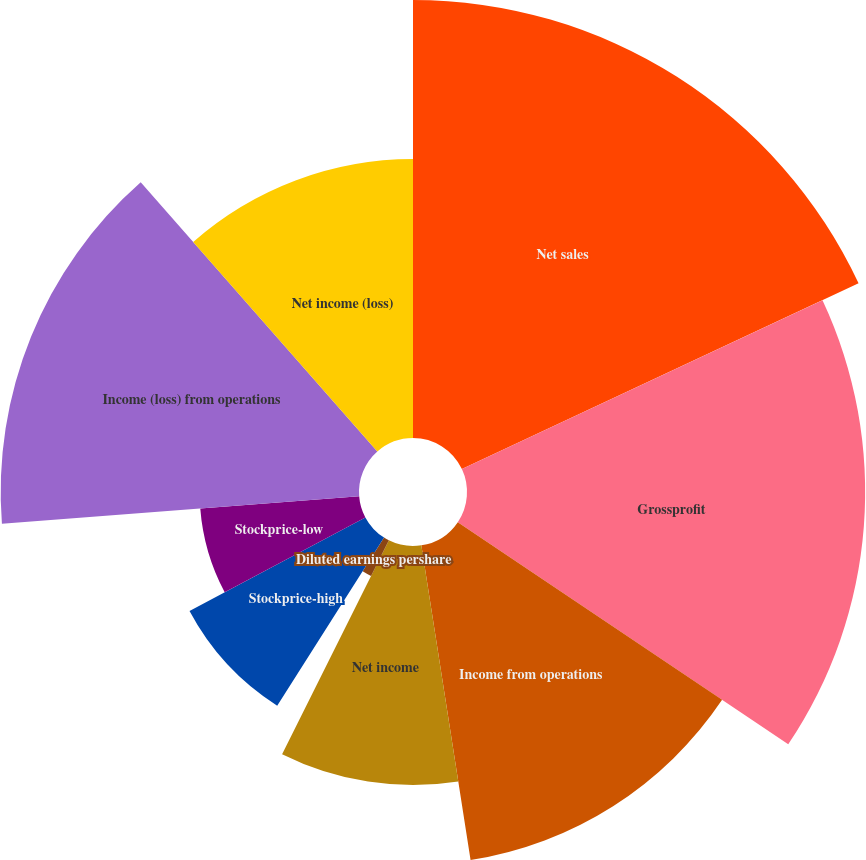<chart> <loc_0><loc_0><loc_500><loc_500><pie_chart><fcel>Net sales<fcel>Grossprofit<fcel>Income from operations<fcel>Net income<fcel>Basic earnings pershare<fcel>Diluted earnings pershare<fcel>Stockprice-high<fcel>Stockprice-low<fcel>Income (loss) from operations<fcel>Net income (loss)<nl><fcel>18.03%<fcel>16.39%<fcel>13.11%<fcel>9.84%<fcel>0.0%<fcel>1.64%<fcel>8.2%<fcel>6.56%<fcel>14.75%<fcel>11.48%<nl></chart> 